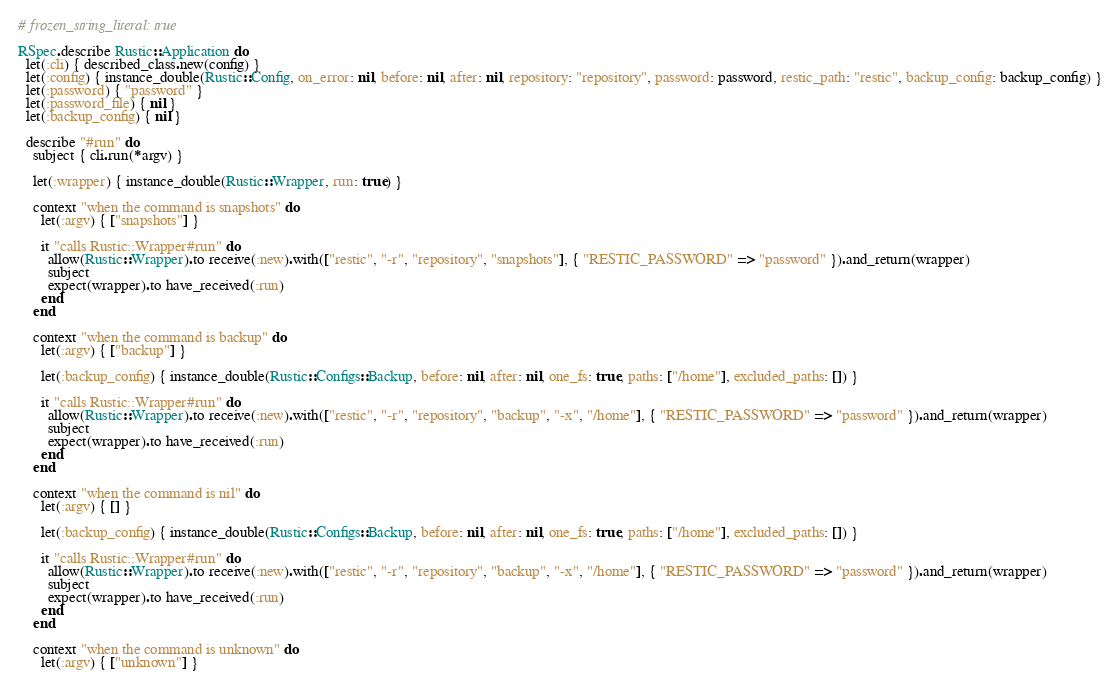<code> <loc_0><loc_0><loc_500><loc_500><_Ruby_># frozen_string_literal: true

RSpec.describe Rustic::Application do
  let(:cli) { described_class.new(config) }
  let(:config) { instance_double(Rustic::Config, on_error: nil, before: nil, after: nil, repository: "repository", password: password, restic_path: "restic", backup_config: backup_config) }
  let(:password) { "password" }
  let(:password_file) { nil }
  let(:backup_config) { nil }

  describe "#run" do
    subject { cli.run(*argv) }

    let(:wrapper) { instance_double(Rustic::Wrapper, run: true) }

    context "when the command is snapshots" do
      let(:argv) { ["snapshots"] }

      it "calls Rustic::Wrapper#run" do
        allow(Rustic::Wrapper).to receive(:new).with(["restic", "-r", "repository", "snapshots"], { "RESTIC_PASSWORD" => "password" }).and_return(wrapper)
        subject
        expect(wrapper).to have_received(:run)
      end
    end

    context "when the command is backup" do
      let(:argv) { ["backup"] }

      let(:backup_config) { instance_double(Rustic::Configs::Backup, before: nil, after: nil, one_fs: true, paths: ["/home"], excluded_paths: []) }

      it "calls Rustic::Wrapper#run" do
        allow(Rustic::Wrapper).to receive(:new).with(["restic", "-r", "repository", "backup", "-x", "/home"], { "RESTIC_PASSWORD" => "password" }).and_return(wrapper)
        subject
        expect(wrapper).to have_received(:run)
      end
    end

    context "when the command is nil" do
      let(:argv) { [] }

      let(:backup_config) { instance_double(Rustic::Configs::Backup, before: nil, after: nil, one_fs: true, paths: ["/home"], excluded_paths: []) }

      it "calls Rustic::Wrapper#run" do
        allow(Rustic::Wrapper).to receive(:new).with(["restic", "-r", "repository", "backup", "-x", "/home"], { "RESTIC_PASSWORD" => "password" }).and_return(wrapper)
        subject
        expect(wrapper).to have_received(:run)
      end
    end

    context "when the command is unknown" do
      let(:argv) { ["unknown"] }
</code> 